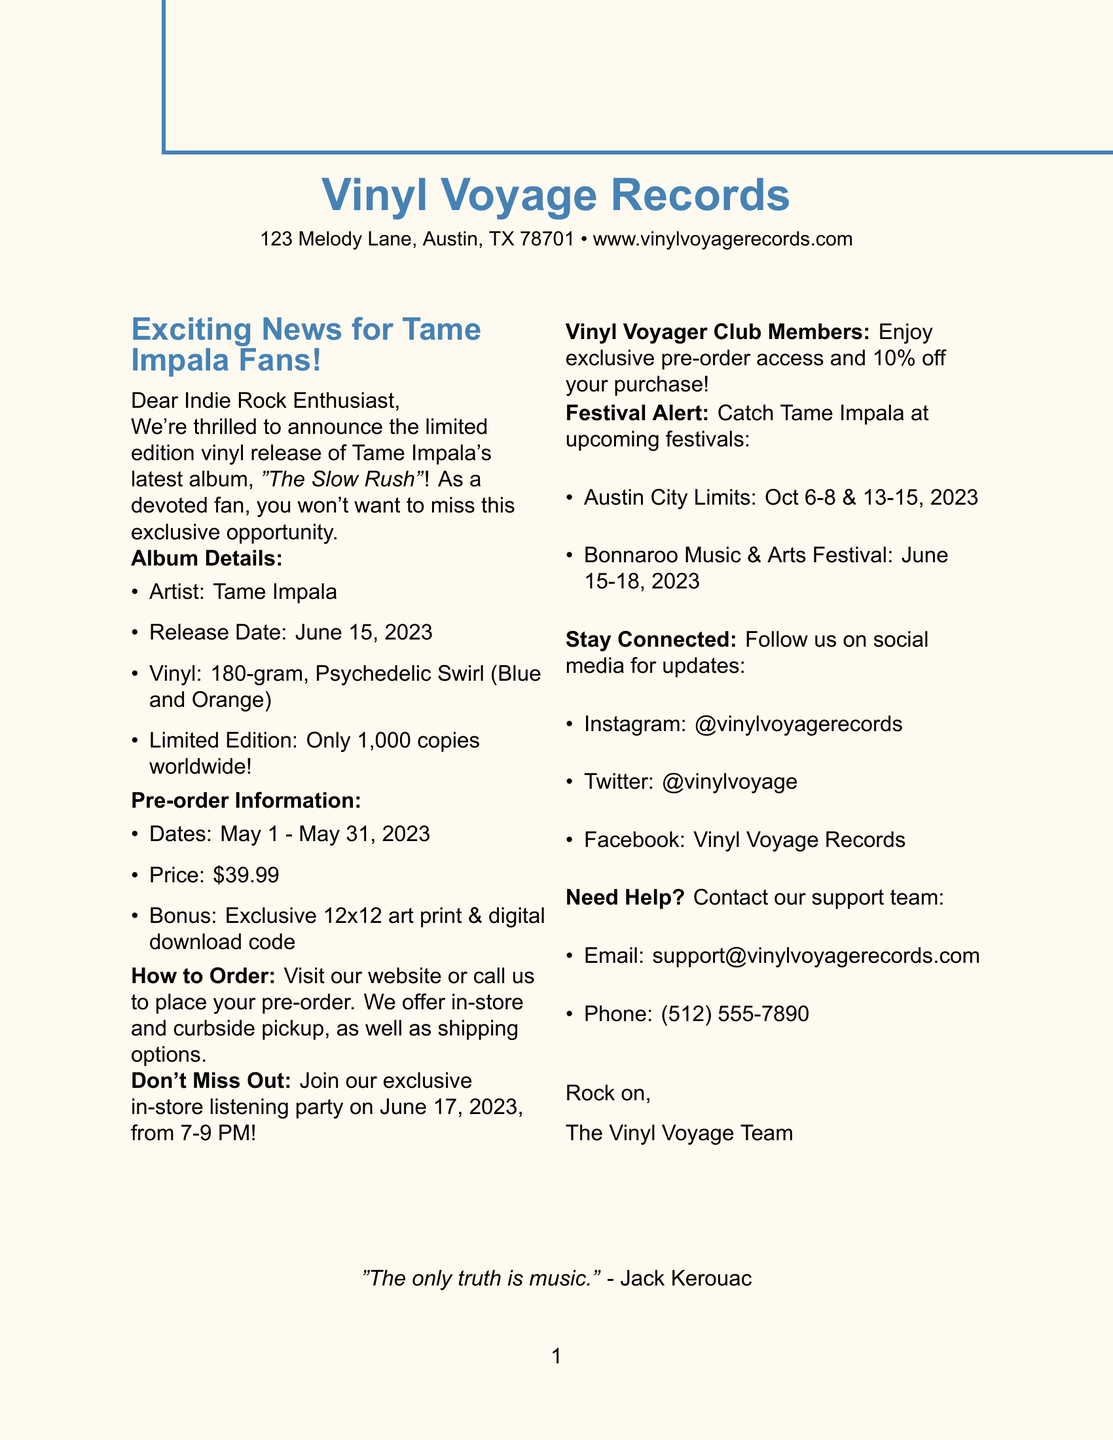What is the store's name? The store's name is mentioned at the top of the document and is "Vinyl Voyage Records."
Answer: Vinyl Voyage Records When does the pre-order period end? The document states the pre-order end date is May 31, 2023.
Answer: May 31, 2023 How many copies of the album are available worldwide? The document specifies that this edition is limited to 1,000 copies worldwide.
Answer: 1,000 copies What color is the vinyl? The document provides details that the vinyl color is "Psychedelic Swirl (Blue and Orange)."
Answer: Psychedelic Swirl (Blue and Orange) What bonus items are included with the album? The document lists an exclusive 12x12 art print and a download code for the digital version as bonus items.
Answer: Exclusive 12x12 art print, download code What payment methods are accepted at the store? The document specifies three payment methods: credit card, PayPal, and Apple Pay.
Answer: Credit card, PayPal, Apple Pay What event will occur on June 17, 2023? The document mentions an exclusive in-store listening party for pre-order customers on that date.
Answer: Exclusive in-store listening party Which festival will Tame Impala perform at in October 2023? The document lists "Austin City Limits" as a festival where Tame Impala will perform in October.
Answer: Austin City Limits What is a perk of joining the Vinyl Voyager Club? The document highlights exclusive pre-order access as one of the benefits of becoming a member.
Answer: Exclusive pre-order access 